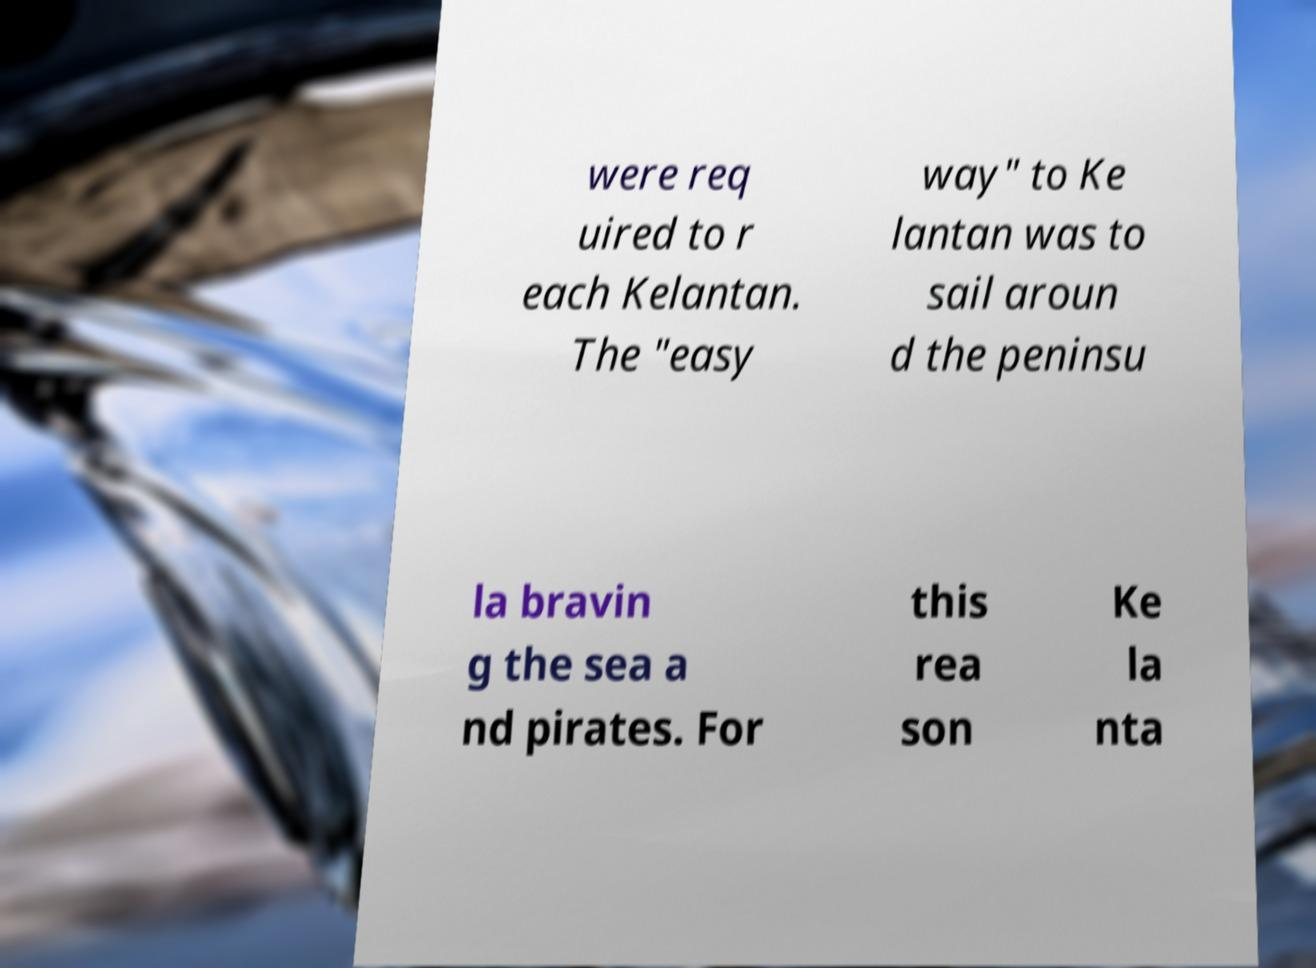Could you assist in decoding the text presented in this image and type it out clearly? were req uired to r each Kelantan. The "easy way" to Ke lantan was to sail aroun d the peninsu la bravin g the sea a nd pirates. For this rea son Ke la nta 